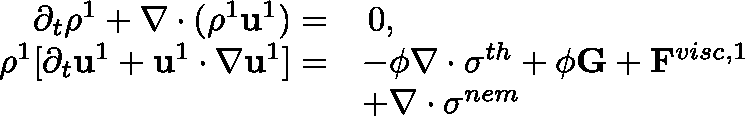<formula> <loc_0><loc_0><loc_500><loc_500>\begin{array} { r l } { \partial _ { t } \rho ^ { 1 } + \nabla \cdot ( \rho ^ { 1 } u ^ { 1 } ) = } & { \, 0 , } \\ { \rho ^ { 1 } [ \partial _ { t } u ^ { 1 } + u ^ { 1 } \cdot \nabla u ^ { 1 } ] = } & { - \phi \nabla \cdot \sigma ^ { t h } + \phi G + F ^ { v i s c , 1 } } \\ & { + \nabla \cdot \sigma ^ { n e m } } \end{array}</formula> 